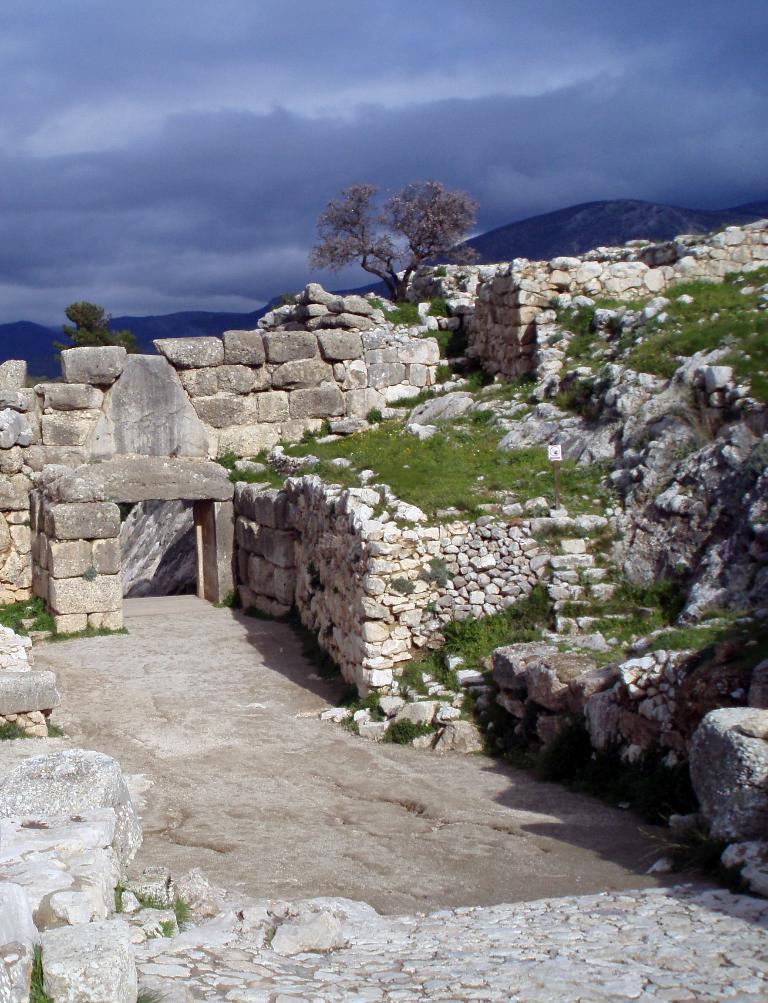How would you summarize this image in a sentence or two? In the image i can see the stones,grass,trees,mountains and in the background i can see the sky. 